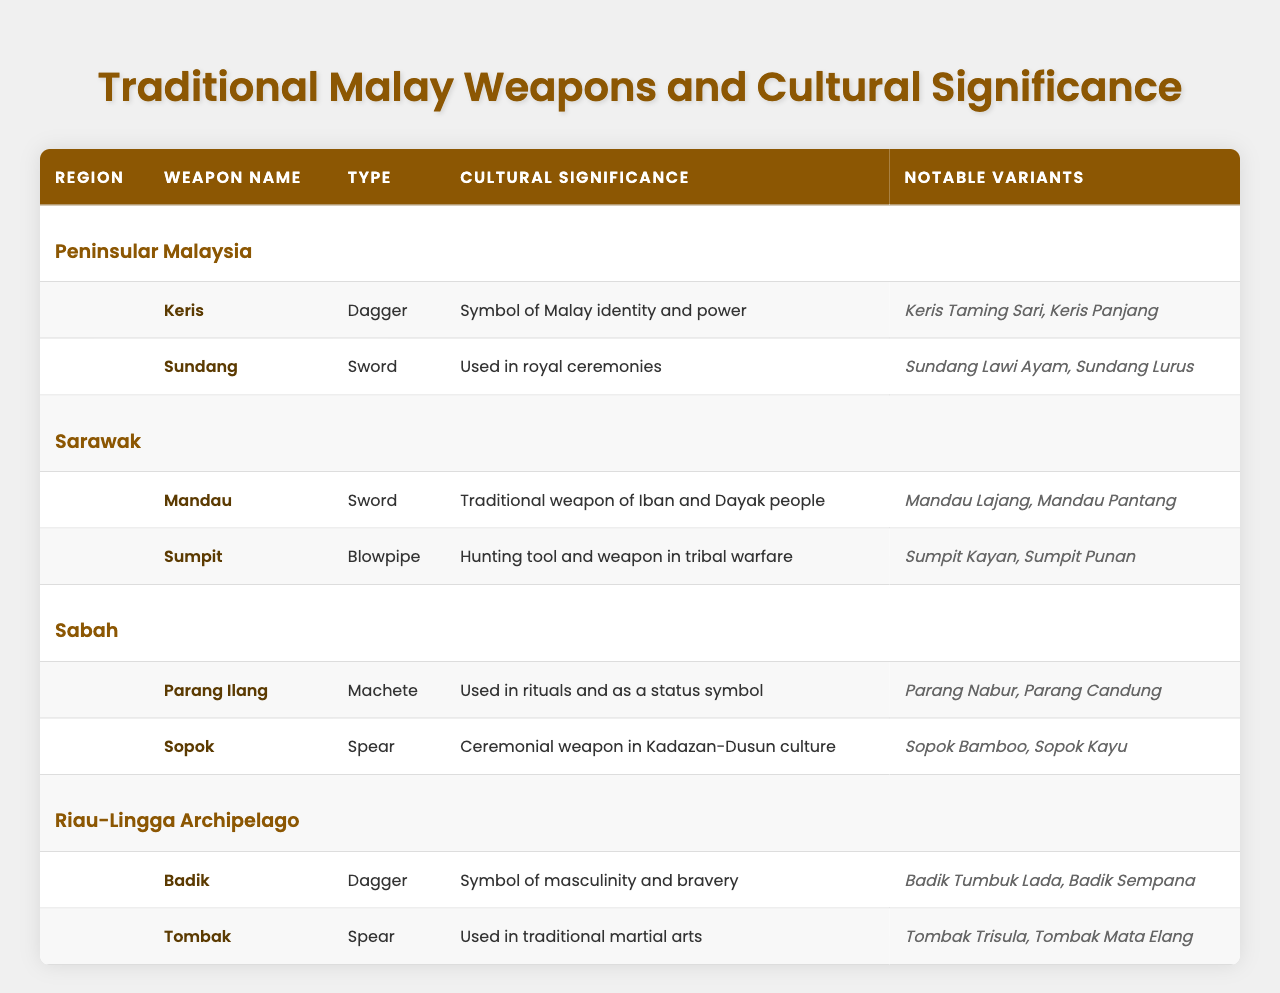What are the notable variants of the Keris? From the table, the notable variants listed under the Keris are "Keris Taming Sari" and "Keris Panjang."
Answer: Keris Taming Sari, Keris Panjang Which region is associated with the Mandau weapon? The table indicates that the Mandau is a traditional weapon of the Iban and Dayak people from Sarawak.
Answer: Sarawak How many different types of weapons are listed from Peninsular Malaysia? The table shows that there are two different types of weapons listed from Peninsular Malaysia: the Keris (dagger) and the Sundang (sword).
Answer: 2 What is the cultural significance of the Parang Ilang? The Parang Ilang is used in rituals and as a status symbol, as stated in the table.
Answer: Used in rituals and as a status symbol Is the Sumpit used for hunting? Yes, according to the table, Sumpit is described as a hunting tool and weapon in tribal warfare.
Answer: Yes Which type of weapon from the Riau-Lingga Archipelago is used in traditional martial arts? The table states that the Tombak, categorized as a spear, is used in traditional martial arts.
Answer: Tombak How many weapons are listed for the Sabah region? The table shows that there are two weapons listed from the Sabah region: Parang Ilang and Sopok.
Answer: 2 Name all the regions that feature spear-type weapons. According to the table, the regions with spear-type weapons are Sabah (Sopok) and Riau-Lingga Archipelago (Tombak).
Answer: Sabah, Riau-Lingga Archipelago What is the cultural significance of the Badik weapon? The Badik is characterized as a symbol of masculinity and bravery as per the information in the table.
Answer: Symbol of masculinity and bravery Are there more dagger-type weapons or sword-type weapons mentioned in total across all regions? Counting the types, there are three dagger-type weapons (Keris, Badik) and four sword-type weapons (Sundang, Mandau), thus there are more sword-type weapons overall.
Answer: Sword-type weapons What notable variants correspond to the weapon Sopok? The Sopok has two notable variants listed: "Sopok Bamboo" and "Sopok Kayu" according to the table.
Answer: Sopok Bamboo, Sopok Kayu Which region's weapon is used in royal ceremonies? The Sundang weapon from Peninsular Malaysia is noted to be used in royal ceremonies according to the table.
Answer: Peninsular Malaysia How are the cultural significances of the weapons related to their respective regions? Each region's weapon reflects cultural identities and traditions; for example, the Keris symbolizes Malay identity in Peninsular Malaysia, while the Mandau represents Iban and Dayak heritage in Sarawak, illustrating how weaponry is intertwined with cultural heritage across regions.
Answer: Varied by region, reflecting cultural identities 